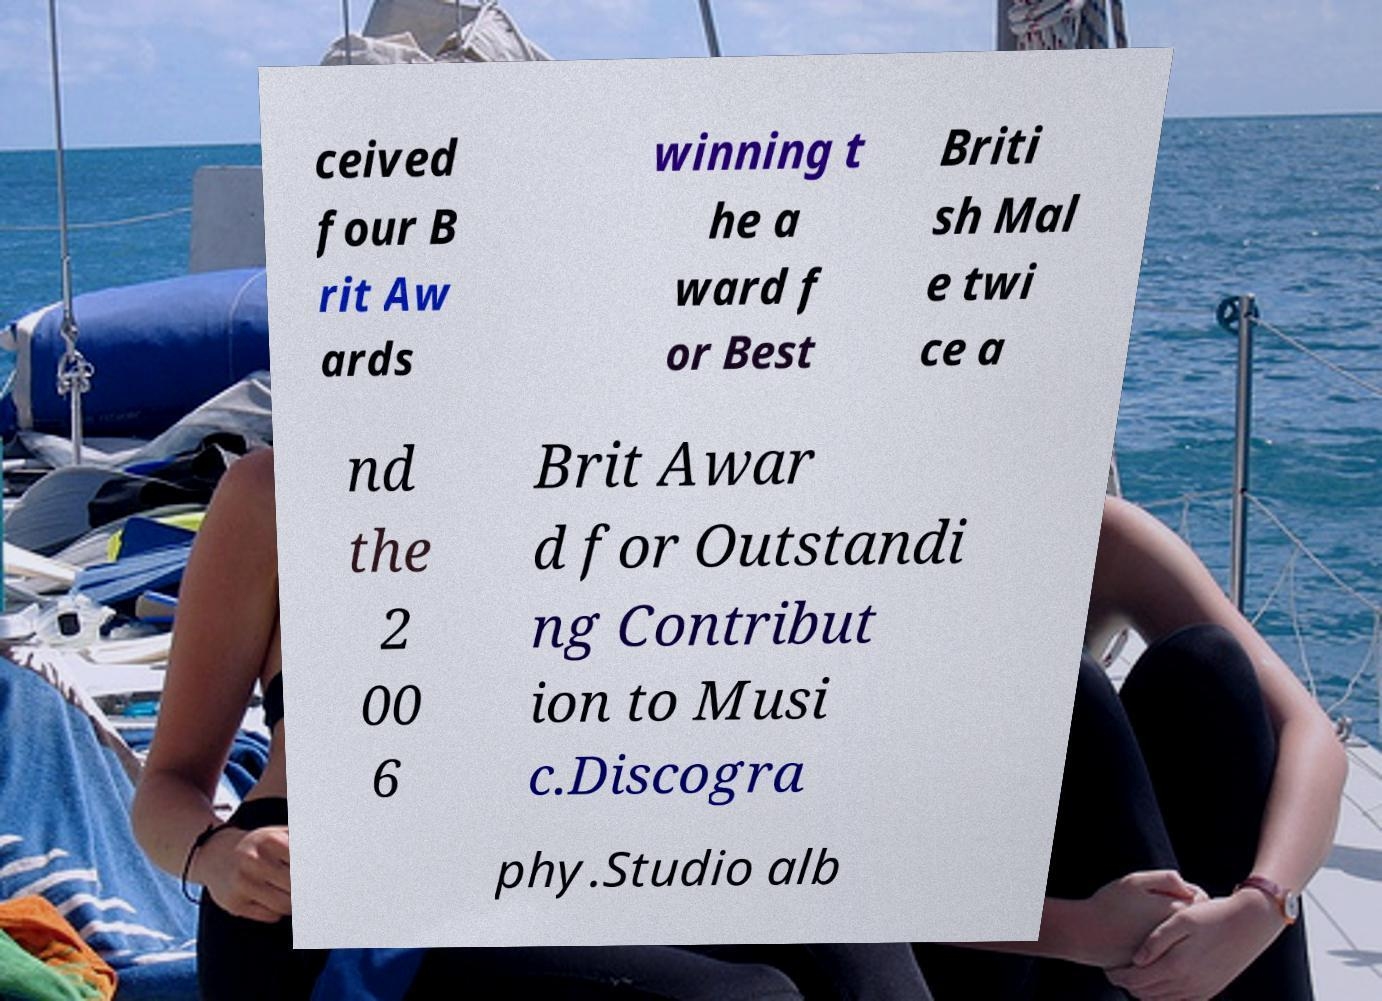Please identify and transcribe the text found in this image. ceived four B rit Aw ards winning t he a ward f or Best Briti sh Mal e twi ce a nd the 2 00 6 Brit Awar d for Outstandi ng Contribut ion to Musi c.Discogra phy.Studio alb 